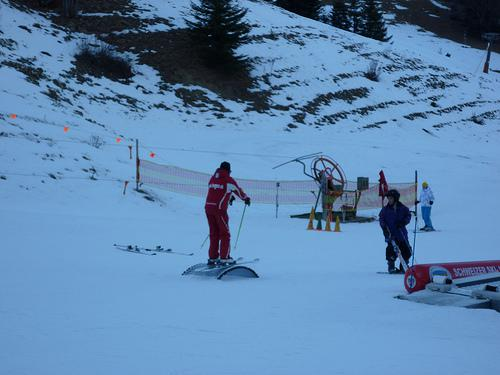Question: where was this picture take?
Choices:
A. The mountains.
B. In the hills.
C. On vacation.
D. Under the trees.
Answer with the letter. Answer: A Question: how many people are there?
Choices:
A. Four.
B. Eight.
C. Eleven.
D. Three.
Answer with the letter. Answer: D 